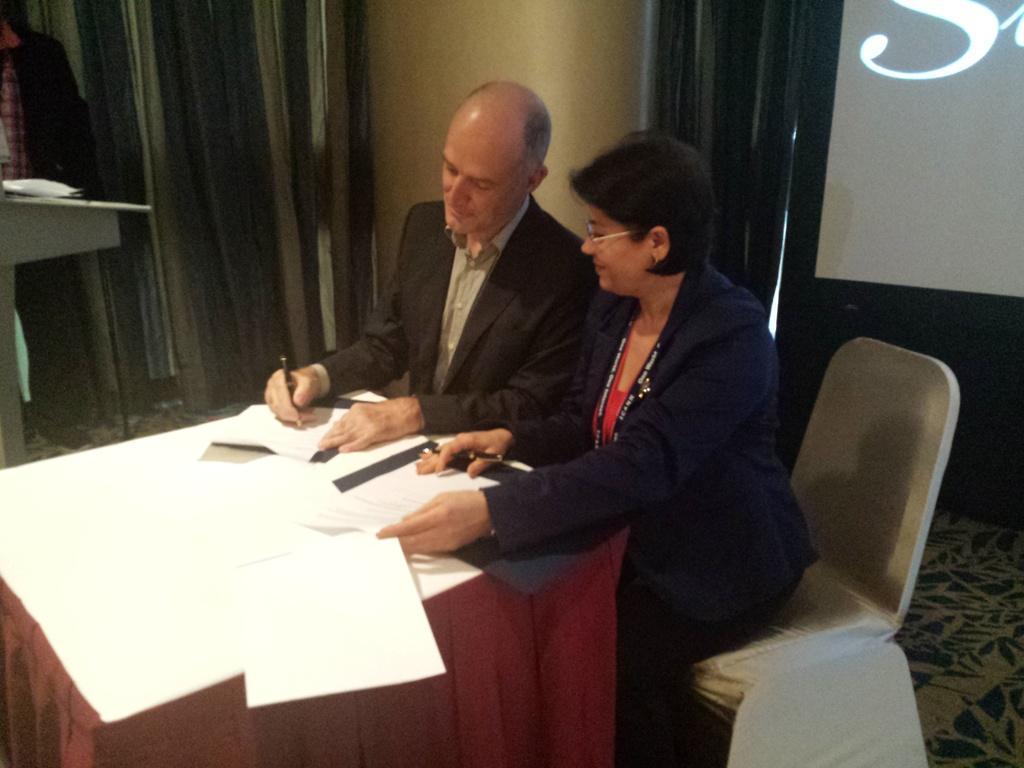How would you summarize this image in a sentence or two? In this image there are chairs and tables. There are papers. There are people. There is a wall. There are curtains. 